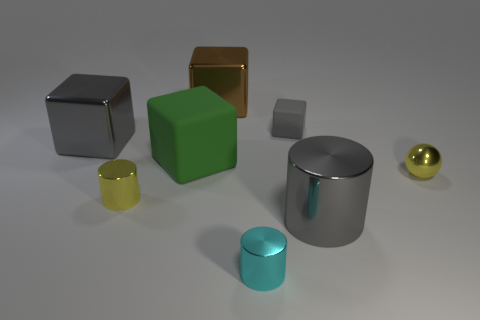What number of things are metallic cubes right of the yellow cylinder or red things?
Provide a short and direct response. 1. What number of brown objects are made of the same material as the small cube?
Your response must be concise. 0. What is the shape of the small rubber object that is the same color as the big metal cylinder?
Your answer should be compact. Cube. Are there the same number of small matte objects to the left of the gray rubber thing and tiny blue matte cubes?
Provide a short and direct response. Yes. How big is the gray block that is to the left of the brown block?
Offer a very short reply. Large. What number of small objects are either green blocks or red balls?
Keep it short and to the point. 0. What is the color of the other small object that is the same shape as the brown object?
Keep it short and to the point. Gray. Does the yellow metal ball have the same size as the cyan cylinder?
Your answer should be compact. Yes. What number of objects are small gray matte spheres or gray cubes that are to the right of the cyan object?
Make the answer very short. 1. What color is the large shiny object that is to the right of the small metal cylinder right of the tiny yellow cylinder?
Your response must be concise. Gray. 